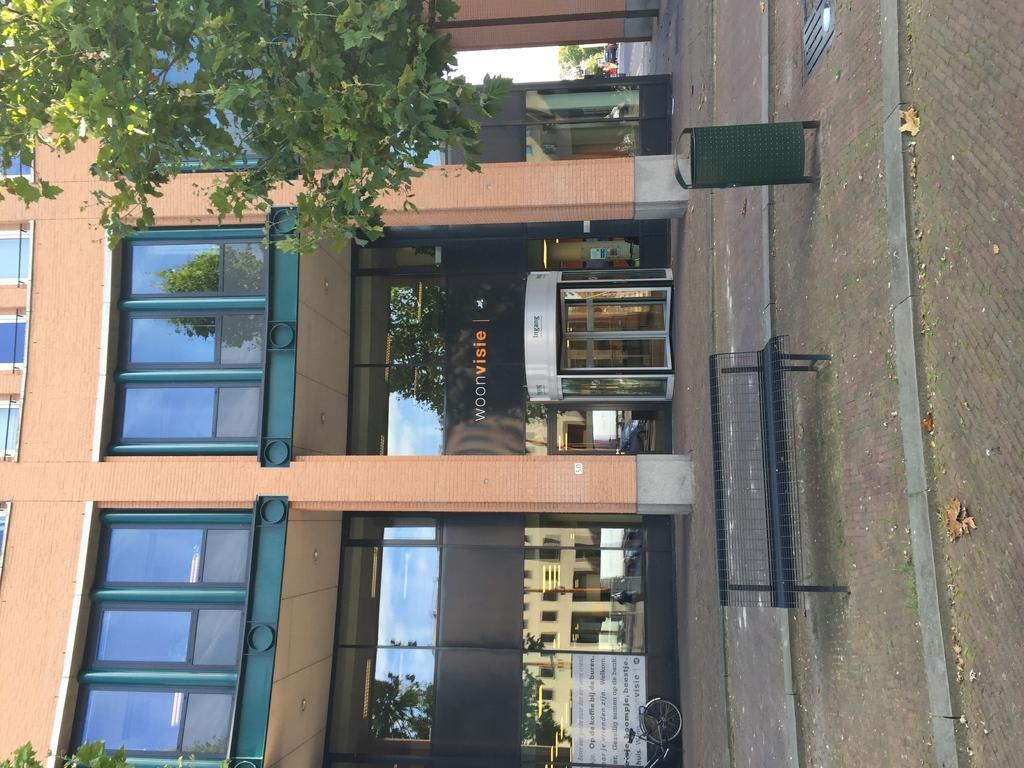What type of structure is visible in the image? There is a building in the image. What object is present for waste disposal? There is a dustbin in the image. What type of seating is available in the image? There is a bench in the image. What type of plant is visible in the image? There is a tree in the image. What type of signage is present in the image? There is a banner in the image. What type of cake is being served at the event depicted in the image? There is no event or cake present in the image; it only features a building, dustbin, bench, tree, and banner. What color is the scarf worn by the person in the image? There is no person or scarf present in the image. 